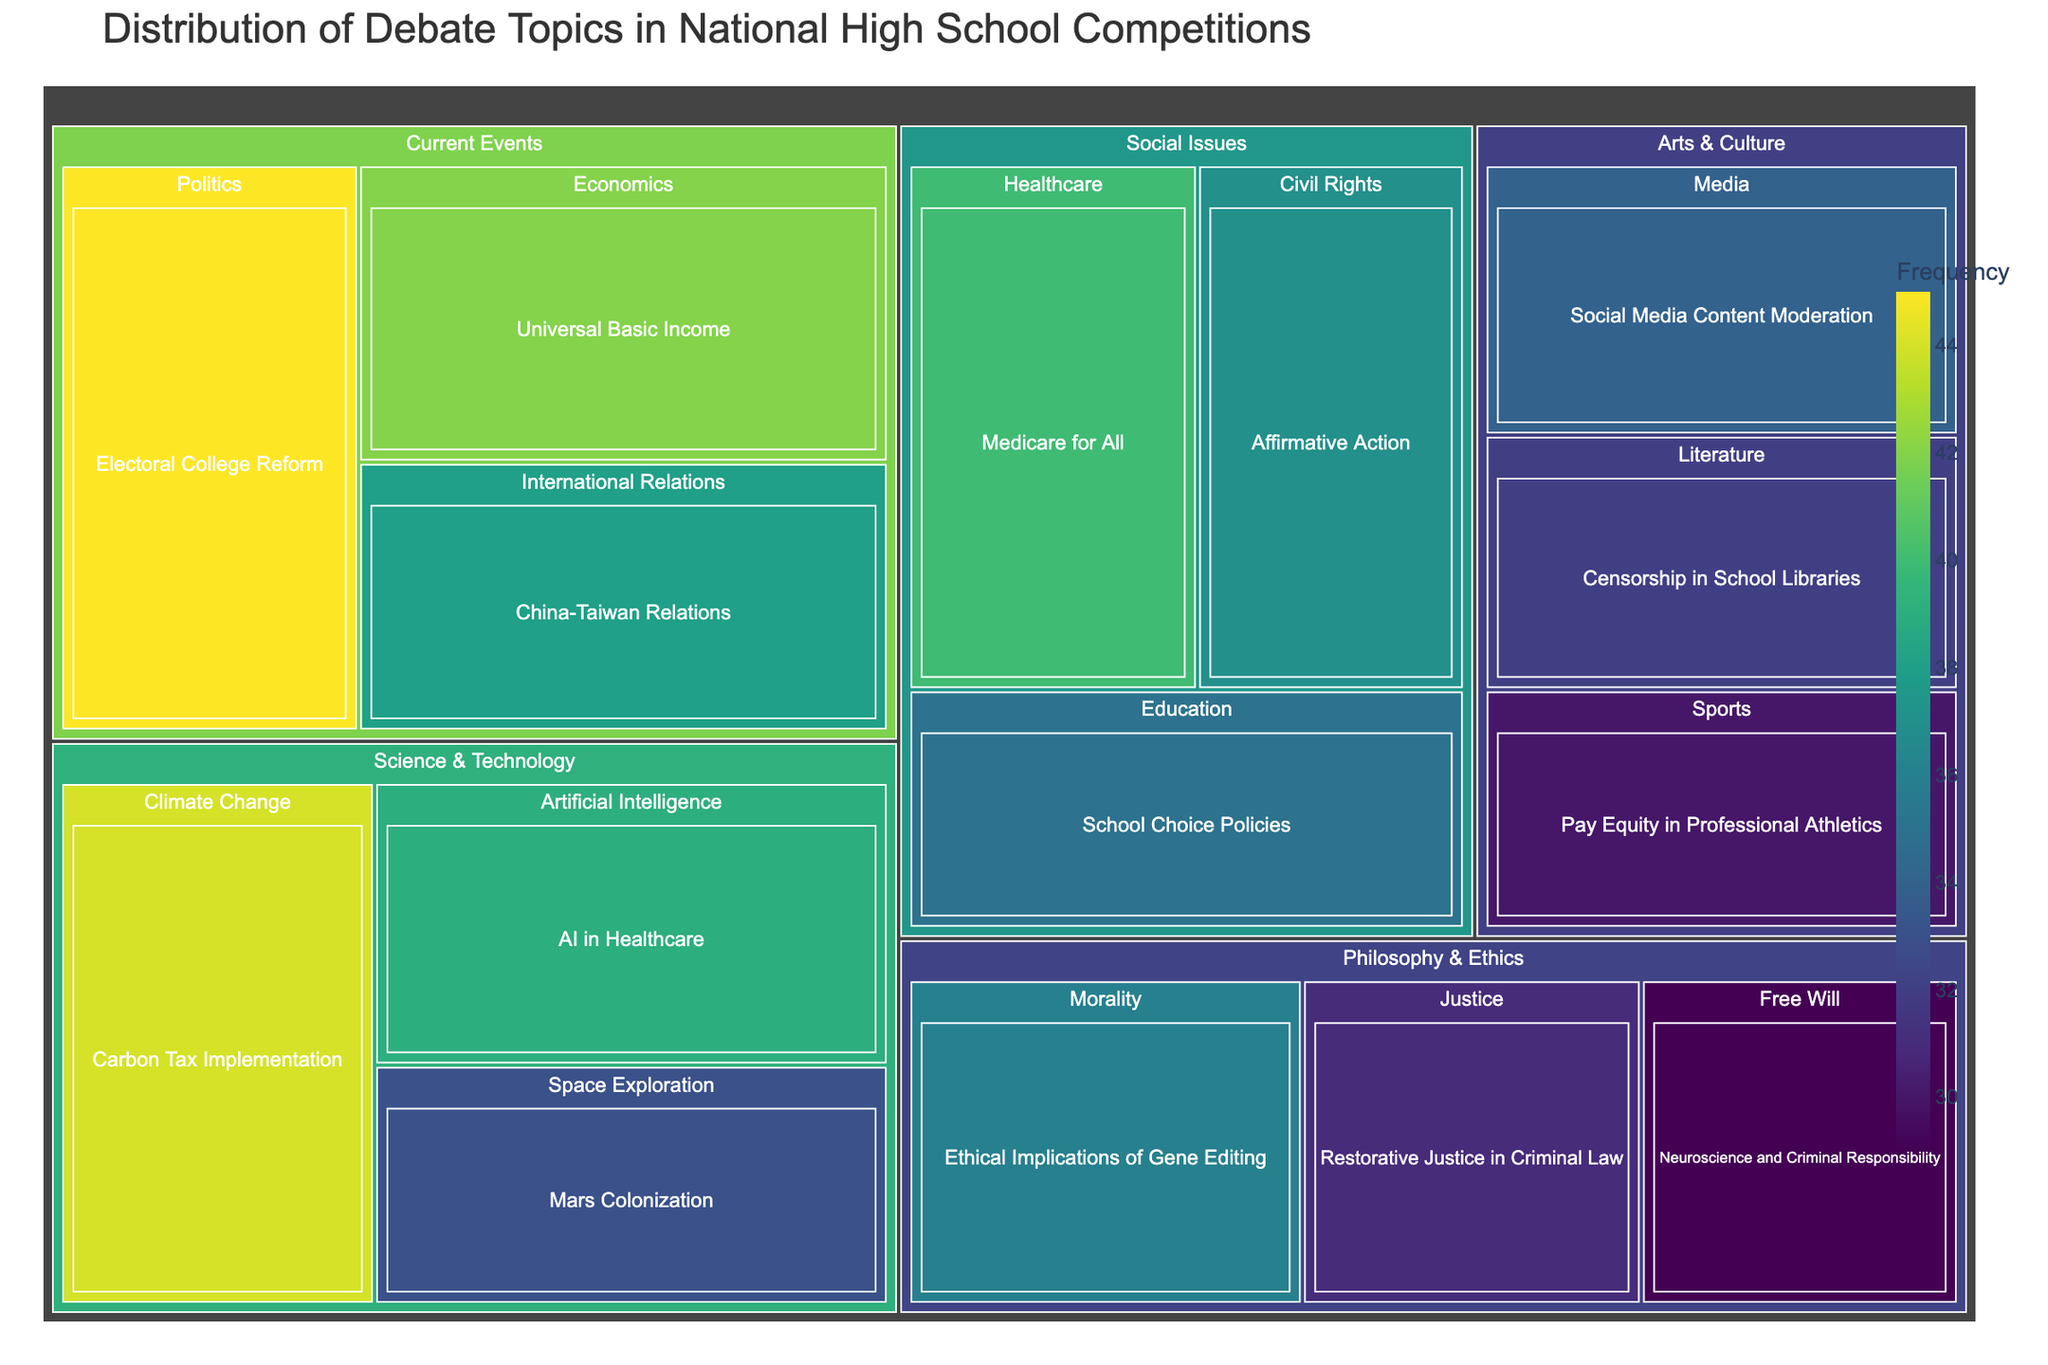what is the topic with the highest frequency? Look for the largest box or the one with the darkest color in the treemap. The size and color intensity are indicative of the frequency. The topic with the frequency of 45 is "Electoral College Reform".
Answer: Electoral College Reform Which category has the most subcategories? Count the number of subcategories within each main category (Current Events, Social Issues, Science & Technology, Philosophy & Ethics, Arts & Culture). Current Events, Social Issues, and Science & Technology each have three subcategories, while Philosophy & Ethics and Arts & Culture have three each, so there is a tie with three subcategories.
Answer: Tie: Current Events, Social Issues, Science & Technology, Philosophy & Ethics, Arts & Culture How many topics have a frequency greater than 40? Identify topics with boxes larger or darker than those with a frequency of 40. There are items with frequencies of 45, 42, and 44, so there are three topics: "Electoral College Reform" (45), "Universal Basic Income" (42), and "Carbon Tax Implementation" (44).
Answer: 3 What is the total frequency of topics under "Social Issues"? Add up the frequencies of all topics under the Social Issues category: "School Choice Policies" (35), "Medicare for All" (40), "Affirmative Action" (37). 35 + 40 + 37 = 112.
Answer: 112 Which subcategory within "Philosophy & Ethics" has the least frequency? Inspect the subcategories within Philosophy & Ethics (Morality, Justice, Free Will) and compare their frequencies. "Free Will" has the frequency of 29, which is the least compared to "Morality" (36) and "Justice" (31).
Answer: Free Will What is the frequency difference between "China-Taiwan Relations" and "AI in Healthcare"? Look at the frequencies for both topics: "China-Taiwan Relations" (38) and "AI in Healthcare" (39). Subtract the frequency of "China-Taiwan Relations" from "AI in Healthcare": 39 - 38 = 1.
Answer: 1 Which topic under "Arts & Culture" has the highest frequency? Compare frequencies within the Arts & Culture category. "Social Media Content Moderation" has the highest frequency with the value of 34.
Answer: Social Media Content Moderation 